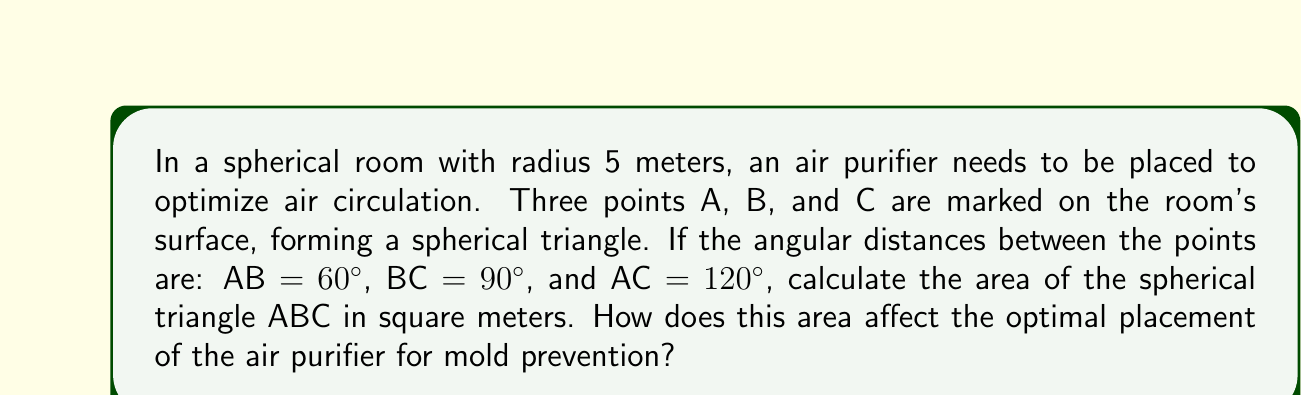Could you help me with this problem? To solve this problem, we'll use the formula for the area of a spherical triangle and then interpret the result in the context of air purifier placement.

Step 1: Recall the formula for the area of a spherical triangle
The area $A$ of a spherical triangle on a sphere of radius $r$ is given by:

$$A = r^2(α + β + γ - π)$$

where $α$, $β$, and $γ$ are the angles of the spherical triangle in radians, and $π$ is pi.

Step 2: Convert the given angular distances to radians
AB = 60° = $\frac{π}{3}$ radians
BC = 90° = $\frac{π}{2}$ radians
AC = 120° = $\frac{2π}{3}$ radians

Step 3: Use the spherical law of cosines to find the angles
For a spherical triangle with sides a, b, and c, and opposite angles A, B, and C:

$$\cos(a) = \cos(b)\cos(c) + \sin(b)\sin(c)\cos(A)$$

Rearranging to solve for $\cos(A)$:

$$\cos(A) = \frac{\cos(a) - \cos(b)\cos(c)}{\sin(b)\sin(c)}$$

Using this formula for each angle:

$$\cos(A) = \frac{\cos(\frac{2π}{3}) - \cos(\frac{π}{3})\cos(\frac{π}{2})}{\sin(\frac{π}{3})\sin(\frac{π}{2})} = -\frac{1}{2}$$

$$A = \arccos(-\frac{1}{2}) = \frac{2π}{3}$$

Similarly, $B = \frac{π}{2}$ and $C = \frac{π}{3}$

Step 4: Calculate the area
Substituting into the area formula:

$$A = 5^2(\frac{2π}{3} + \frac{π}{2} + \frac{π}{3} - π) = 25(\frac{3π}{2} - π) = 25 \cdot \frac{π}{2} = \frac{25π}{2}$$

Step 5: Convert to square meters
Area = $\frac{25π}{2} ≈ 39.27$ square meters

Interpretation: The large area of the spherical triangle (about 39.27 m²) suggests that the air purifier should be placed centrally within this triangle to ensure optimal coverage. This placement will help prevent mold growth by maintaining consistent air circulation throughout the room, especially in the corners and along the curved surfaces where moisture might accumulate.
Answer: 39.27 m²; central placement within the triangle for optimal mold prevention 